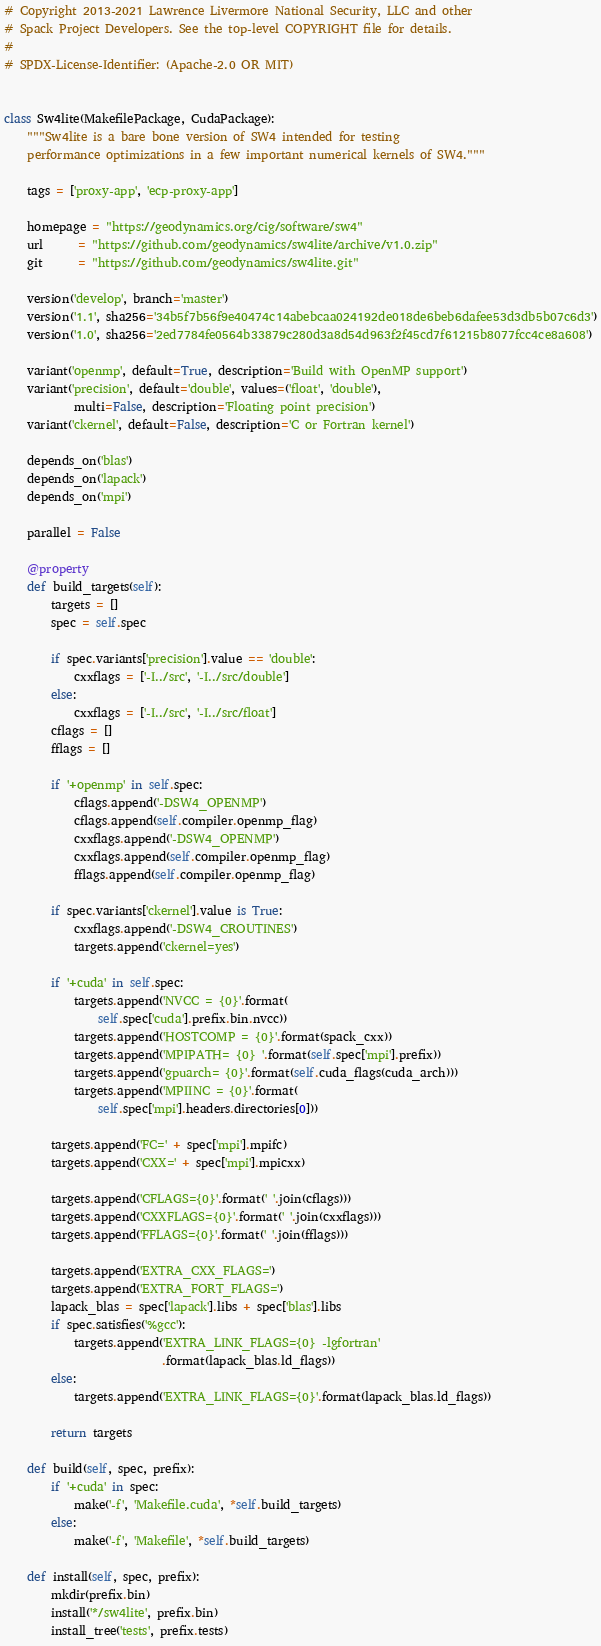Convert code to text. <code><loc_0><loc_0><loc_500><loc_500><_Python_># Copyright 2013-2021 Lawrence Livermore National Security, LLC and other
# Spack Project Developers. See the top-level COPYRIGHT file for details.
#
# SPDX-License-Identifier: (Apache-2.0 OR MIT)


class Sw4lite(MakefilePackage, CudaPackage):
    """Sw4lite is a bare bone version of SW4 intended for testing
    performance optimizations in a few important numerical kernels of SW4."""

    tags = ['proxy-app', 'ecp-proxy-app']

    homepage = "https://geodynamics.org/cig/software/sw4"
    url      = "https://github.com/geodynamics/sw4lite/archive/v1.0.zip"
    git      = "https://github.com/geodynamics/sw4lite.git"

    version('develop', branch='master')
    version('1.1', sha256='34b5f7b56f9e40474c14abebcaa024192de018de6beb6dafee53d3db5b07c6d3')
    version('1.0', sha256='2ed7784fe0564b33879c280d3a8d54d963f2f45cd7f61215b8077fcc4ce8a608')

    variant('openmp', default=True, description='Build with OpenMP support')
    variant('precision', default='double', values=('float', 'double'),
            multi=False, description='Floating point precision')
    variant('ckernel', default=False, description='C or Fortran kernel')

    depends_on('blas')
    depends_on('lapack')
    depends_on('mpi')

    parallel = False

    @property
    def build_targets(self):
        targets = []
        spec = self.spec

        if spec.variants['precision'].value == 'double':
            cxxflags = ['-I../src', '-I../src/double']
        else:
            cxxflags = ['-I../src', '-I../src/float']
        cflags = []
        fflags = []

        if '+openmp' in self.spec:
            cflags.append('-DSW4_OPENMP')
            cflags.append(self.compiler.openmp_flag)
            cxxflags.append('-DSW4_OPENMP')
            cxxflags.append(self.compiler.openmp_flag)
            fflags.append(self.compiler.openmp_flag)

        if spec.variants['ckernel'].value is True:
            cxxflags.append('-DSW4_CROUTINES')
            targets.append('ckernel=yes')

        if '+cuda' in self.spec:
            targets.append('NVCC = {0}'.format(
                self.spec['cuda'].prefix.bin.nvcc))
            targets.append('HOSTCOMP = {0}'.format(spack_cxx))
            targets.append('MPIPATH= {0} '.format(self.spec['mpi'].prefix))
            targets.append('gpuarch= {0}'.format(self.cuda_flags(cuda_arch)))
            targets.append('MPIINC = {0}'.format(
                self.spec['mpi'].headers.directories[0]))

        targets.append('FC=' + spec['mpi'].mpifc)
        targets.append('CXX=' + spec['mpi'].mpicxx)

        targets.append('CFLAGS={0}'.format(' '.join(cflags)))
        targets.append('CXXFLAGS={0}'.format(' '.join(cxxflags)))
        targets.append('FFLAGS={0}'.format(' '.join(fflags)))

        targets.append('EXTRA_CXX_FLAGS=')
        targets.append('EXTRA_FORT_FLAGS=')
        lapack_blas = spec['lapack'].libs + spec['blas'].libs
        if spec.satisfies('%gcc'):
            targets.append('EXTRA_LINK_FLAGS={0} -lgfortran'
                           .format(lapack_blas.ld_flags))
        else:
            targets.append('EXTRA_LINK_FLAGS={0}'.format(lapack_blas.ld_flags))

        return targets

    def build(self, spec, prefix):
        if '+cuda' in spec:
            make('-f', 'Makefile.cuda', *self.build_targets)
        else:
            make('-f', 'Makefile', *self.build_targets)

    def install(self, spec, prefix):
        mkdir(prefix.bin)
        install('*/sw4lite', prefix.bin)
        install_tree('tests', prefix.tests)
</code> 